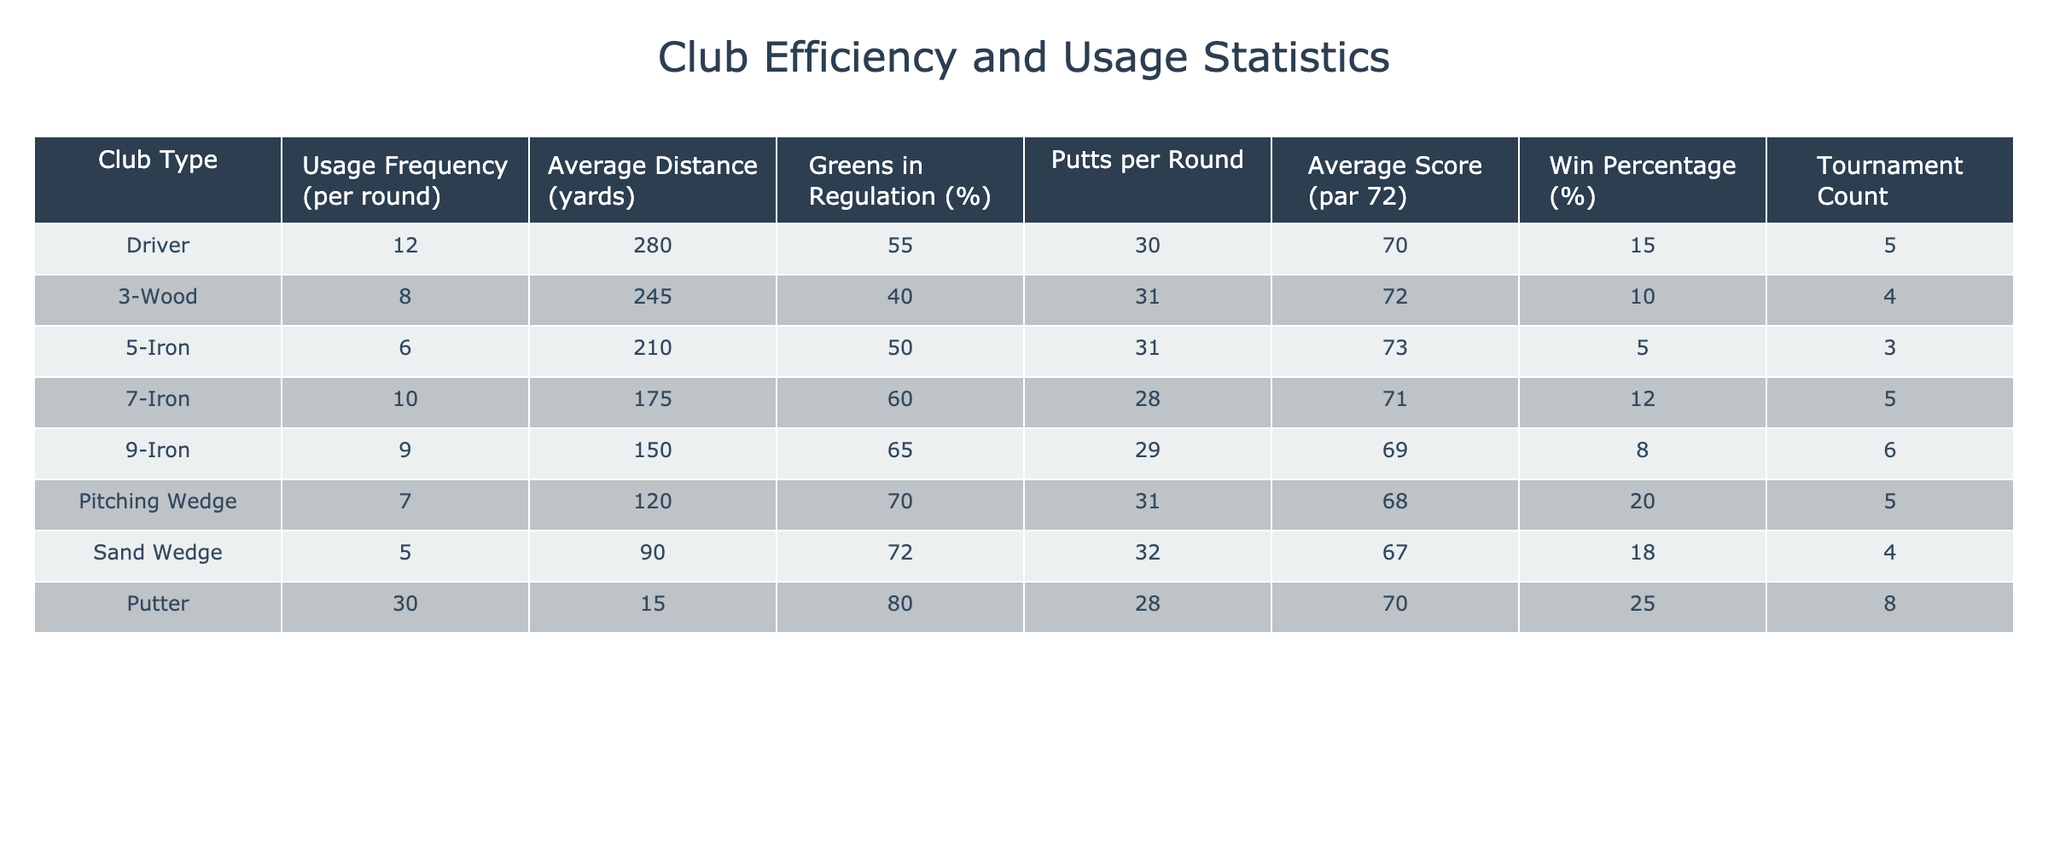What is the usage frequency of the Driver? The usage frequency of each club type is directly listed in the table. For the Driver, it shows 12.
Answer: 12 Which club type has the highest percentage of Greens in Regulation? The table lists the Greens in Regulation percentages for each club. The Pitching Wedge has 70%, which is the highest among all listed clubs.
Answer: Pitching Wedge What is the average distance for the 7-Iron? The average distance column shows that the 7-Iron has an average distance of 175 yards listed.
Answer: 175 yards Is the Win Percentage of the Sand Wedge greater than 15%? Looking at the Win Percentage column, the Sand Wedge is listed at 18%, which is indeed greater than 15%.
Answer: Yes What is the total usage frequency of the clubs listed in the table? To find the total usage frequency, we add all the usage frequency values together: 12 + 8 + 6 + 10 + 9 + 7 + 5 + 30 = 97.
Answer: 97 Which club type has the lowest average score? The average score column indicates that the Sand Wedge has the lowest average score of 67.
Answer: Sand Wedge What percentage of tournaments did the clubs with Win Percentage over 10% participate in? The clubs with a Win Percentage over 10% are the Driver (15%), 7-Iron (12%), Pitching Wedge (20%), Sand Wedge (18%), and Putter (25%), thus totaling 5 tournaments. The total number of tournaments is 38 (sum of tournament counts: 5 + 4 + 3 + 5 + 6 + 5 + 4 + 8). Therefore, (5/38) * 100 = 13.16%.
Answer: 13.16% Is there any club that has an average distance less than 100 yards? Reviewing the average distance column reveals that the club with the least distance, the Sand Wedge, is listed at 90 yards, which confirms the statement is true.
Answer: Yes What is the average number of putts per round for clubs with a usage frequency greater than 8? The clubs with usage frequencies greater than 8 are Driver (30 putts), 3-Wood (31 putts), 7-Iron (28 putts), 9-Iron (29 putts), and Putter (28 putts). The average number of putts is (30 + 31 + 28 + 29 + 28) / 5 = 29.
Answer: 29 